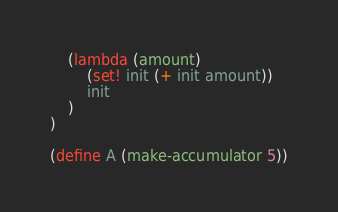<code> <loc_0><loc_0><loc_500><loc_500><_Scheme_>    (lambda (amount)
        (set! init (+ init amount))
        init    
    )
)

(define A (make-accumulator 5))</code> 